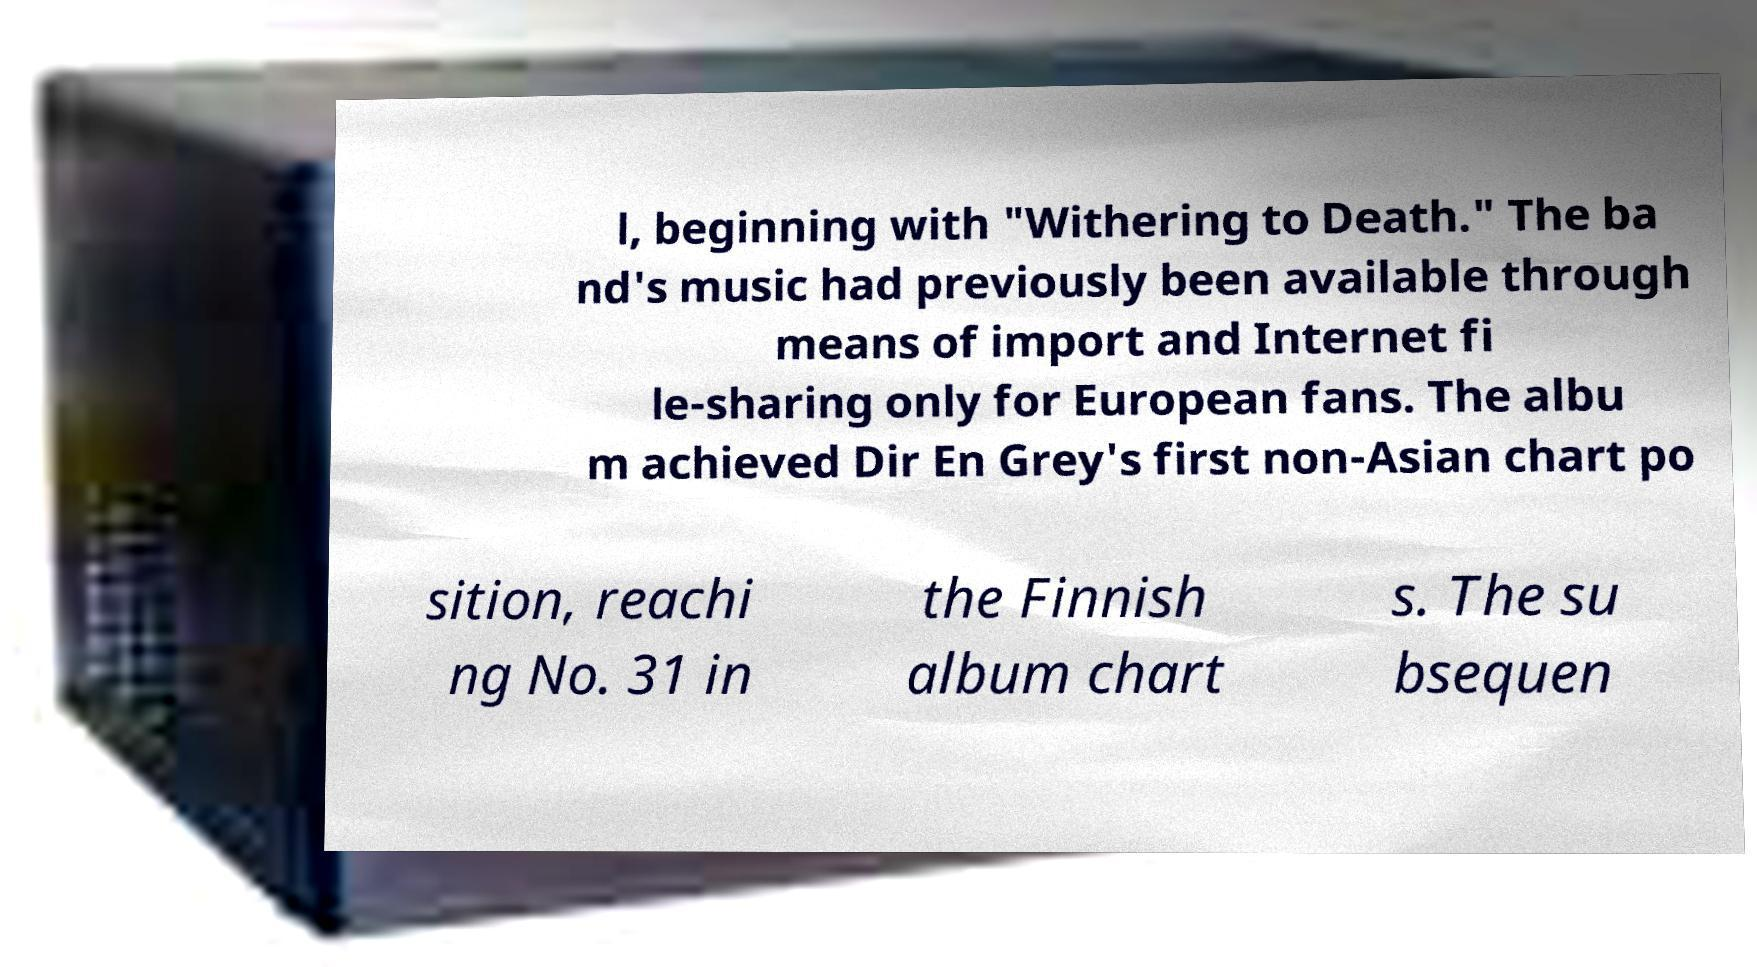Can you accurately transcribe the text from the provided image for me? l, beginning with "Withering to Death." The ba nd's music had previously been available through means of import and Internet fi le-sharing only for European fans. The albu m achieved Dir En Grey's first non-Asian chart po sition, reachi ng No. 31 in the Finnish album chart s. The su bsequen 